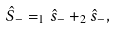<formula> <loc_0><loc_0><loc_500><loc_500>\hat { S } _ { - } = _ { 1 } \hat { s } _ { - } + _ { 2 } \hat { s } _ { - } ,</formula> 